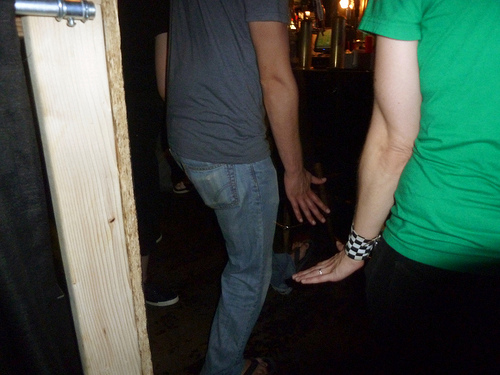<image>
Is there a woman to the right of the wallet? Yes. From this viewpoint, the woman is positioned to the right side relative to the wallet. 